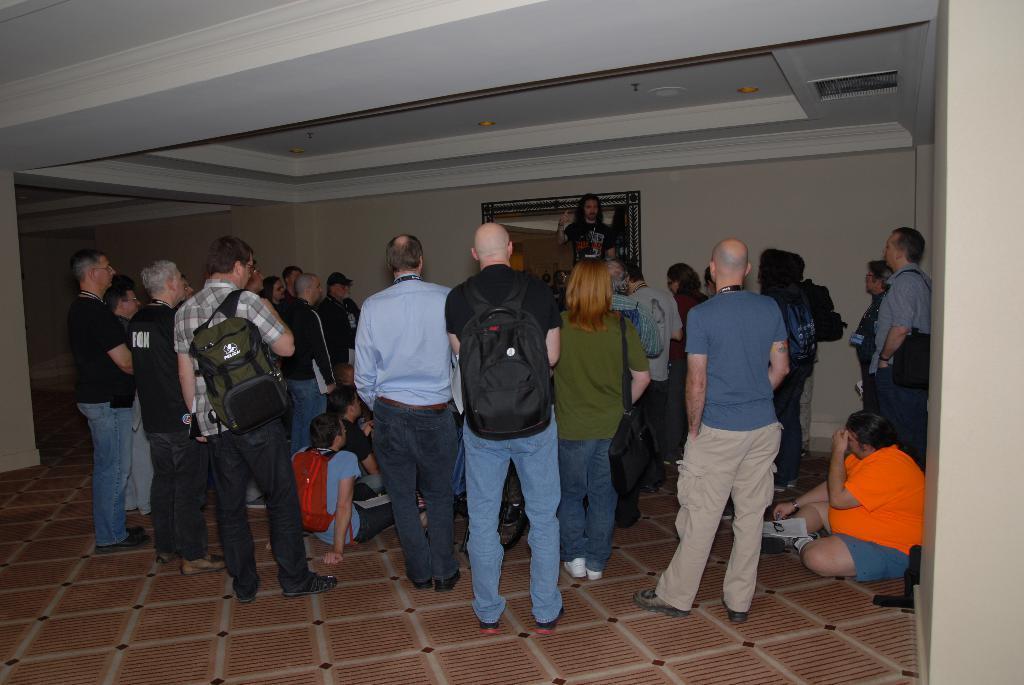Please provide a concise description of this image. In this image few persons are standing the floor. Few persons are sitting on the floor. Left side a person is carrying a bag. Middle of the image there is a person standing on the floor. He is carrying a bag. Background there is a wall having a picture frame attached to it. 